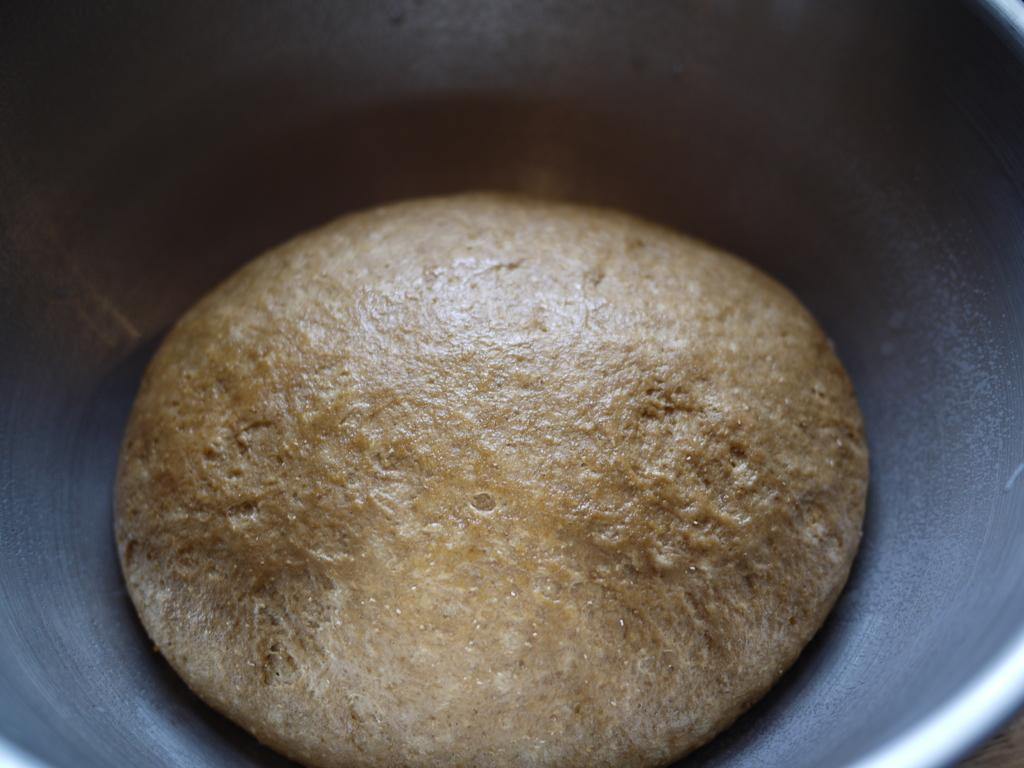What type of bread is in the image? There is whole wheat pita bread in the image. How is the pita bread being stored or displayed in the image? The pita bread is in a bowl. How many sheep are visible in the image? There are no sheep present in the image. Can you tell me how many family members are in the image? There is no reference to a family or any family members in the image. Is there a scarf draped over the pita bread in the image? There is no scarf present in the image. 